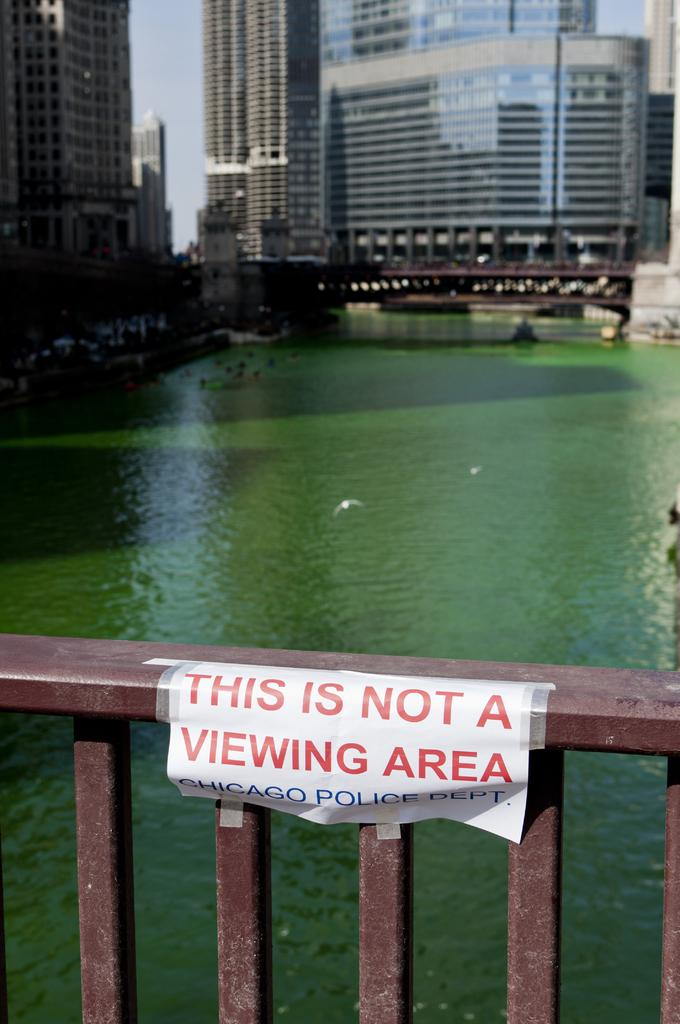What type of structures can be seen in the image? There are buildings with windows in the image. What is the purpose of the fence in the image? The purpose of the fence in the image is not specified, but it could be for enclosing an area or providing a barrier. What is the paper in the image used for? The paper in the image has text on it, which suggests it might be used for writing or communication. What color is the crayon used to draw on the buildings in the image? There is no crayon or drawing present on the buildings in the image. 